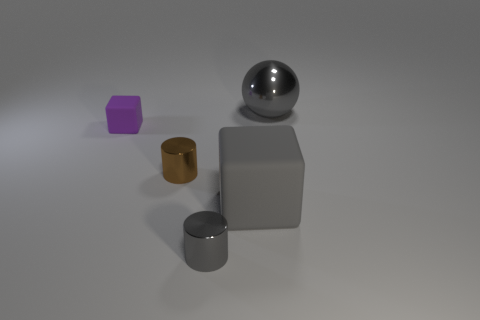Add 1 red metallic cubes. How many objects exist? 6 Subtract all balls. How many objects are left? 4 Add 3 big cubes. How many big cubes exist? 4 Subtract 1 gray balls. How many objects are left? 4 Subtract all gray cylinders. Subtract all blue things. How many objects are left? 4 Add 4 big gray objects. How many big gray objects are left? 6 